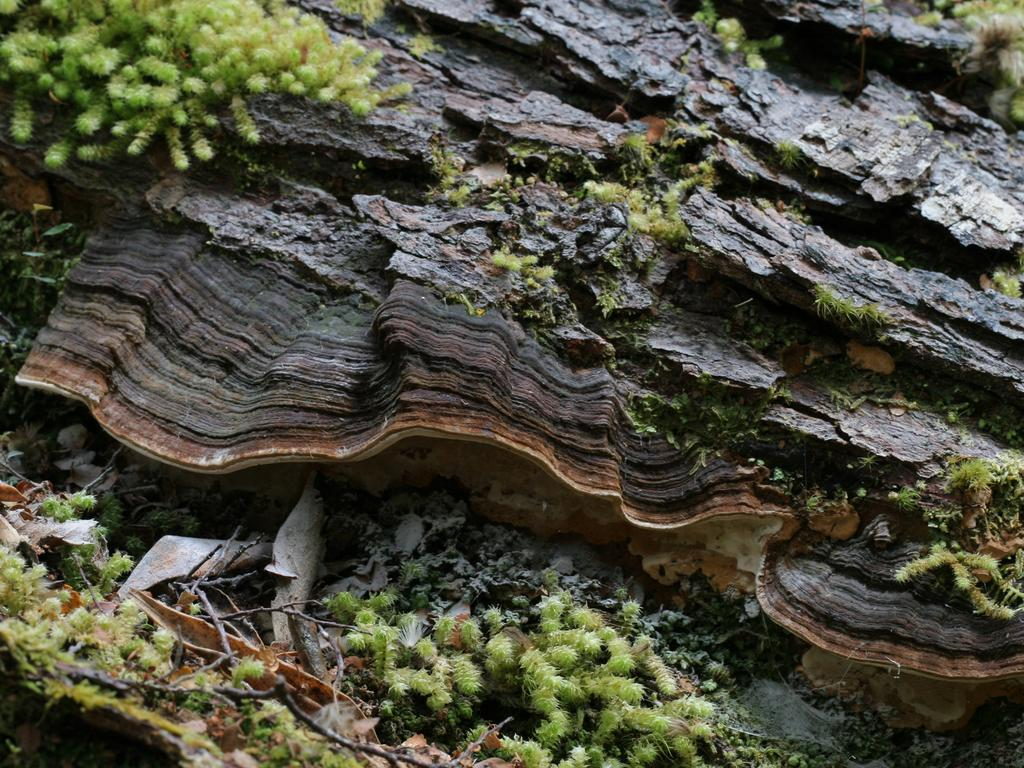What type of plants can be seen in the image? There are tiny plants in the image. What other natural elements are visible in the image? There are twigs and dried leaves present in the image. What material is the branch in the image made of? The branch in the image is made of wood. What type of feast is being prepared by the giants in the image? There are no giants or feast present in the image; it features tiny plants, twigs, dried leaves, and a wooden branch. 